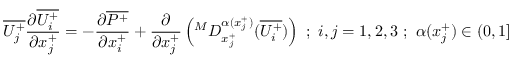<formula> <loc_0><loc_0><loc_500><loc_500>\overline { { U _ { j } ^ { + } } } \frac { \partial \overline { { U _ { i } ^ { + } } } } { \partial x _ { j } ^ { + } } = - \frac { \partial \overline { { P ^ { + } } } } { \partial x _ { i } ^ { + } } + \frac { \partial } { \partial x _ { j } ^ { + } } \left ( ^ { M } D _ { x _ { j } ^ { + } } ^ { \alpha ( x _ { j } ^ { + } ) } ( \overline { { U _ { i } ^ { + } } } ) \right ) ; i , j = 1 , 2 , 3 ; \alpha ( x _ { j } ^ { + } ) \in ( 0 , 1 ]</formula> 